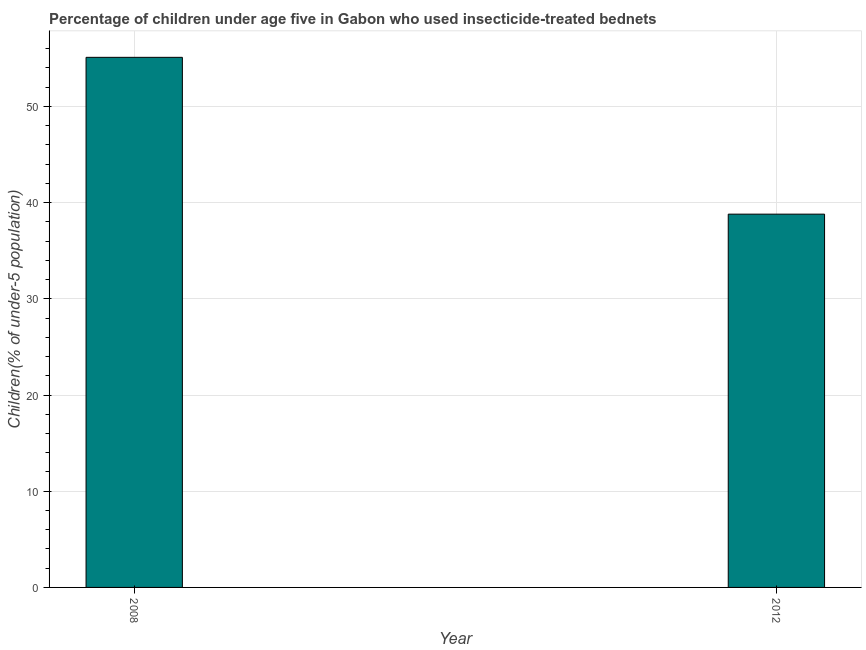What is the title of the graph?
Make the answer very short. Percentage of children under age five in Gabon who used insecticide-treated bednets. What is the label or title of the X-axis?
Offer a very short reply. Year. What is the label or title of the Y-axis?
Your response must be concise. Children(% of under-5 population). What is the percentage of children who use of insecticide-treated bed nets in 2008?
Your answer should be very brief. 55.1. Across all years, what is the maximum percentage of children who use of insecticide-treated bed nets?
Your answer should be very brief. 55.1. Across all years, what is the minimum percentage of children who use of insecticide-treated bed nets?
Ensure brevity in your answer.  38.8. What is the sum of the percentage of children who use of insecticide-treated bed nets?
Offer a terse response. 93.9. What is the difference between the percentage of children who use of insecticide-treated bed nets in 2008 and 2012?
Ensure brevity in your answer.  16.3. What is the average percentage of children who use of insecticide-treated bed nets per year?
Your answer should be compact. 46.95. What is the median percentage of children who use of insecticide-treated bed nets?
Your answer should be very brief. 46.95. Do a majority of the years between 2008 and 2012 (inclusive) have percentage of children who use of insecticide-treated bed nets greater than 14 %?
Your answer should be very brief. Yes. What is the ratio of the percentage of children who use of insecticide-treated bed nets in 2008 to that in 2012?
Your response must be concise. 1.42. How many bars are there?
Provide a succinct answer. 2. What is the difference between two consecutive major ticks on the Y-axis?
Your answer should be very brief. 10. Are the values on the major ticks of Y-axis written in scientific E-notation?
Provide a short and direct response. No. What is the Children(% of under-5 population) in 2008?
Provide a short and direct response. 55.1. What is the Children(% of under-5 population) of 2012?
Give a very brief answer. 38.8. What is the difference between the Children(% of under-5 population) in 2008 and 2012?
Ensure brevity in your answer.  16.3. What is the ratio of the Children(% of under-5 population) in 2008 to that in 2012?
Give a very brief answer. 1.42. 